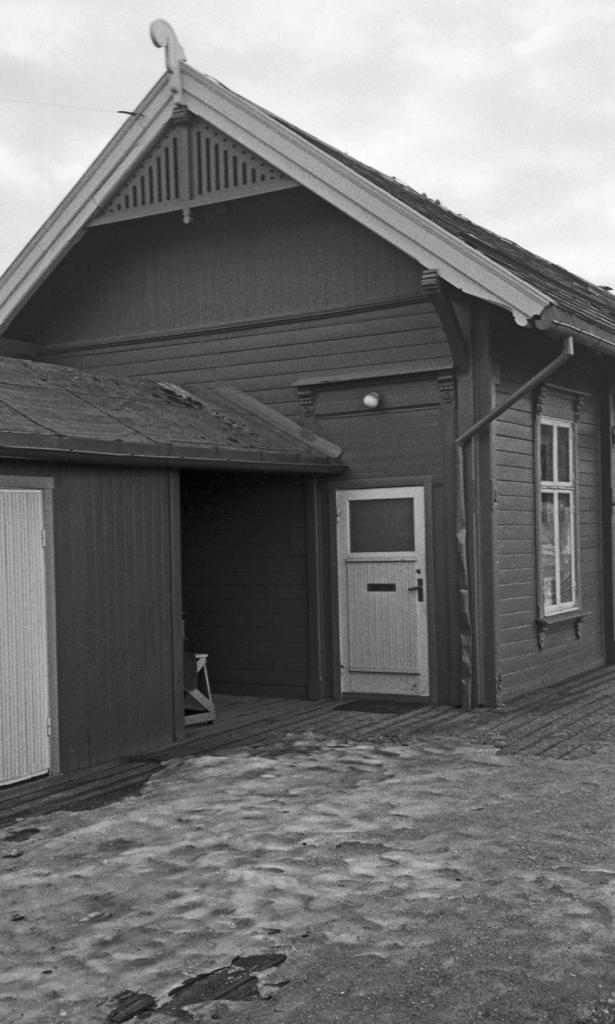What is the color scheme of the image? The image is black and white. What structure can be seen in the image? There is a house in the image. What part of the natural environment is visible in the background of the image? The sky is visible in the background of the image. What type of lace can be seen on the windows of the house in the image? There is no lace visible on the windows of the house in the image, as the image is black and white and does not show any details of the house's interior. 